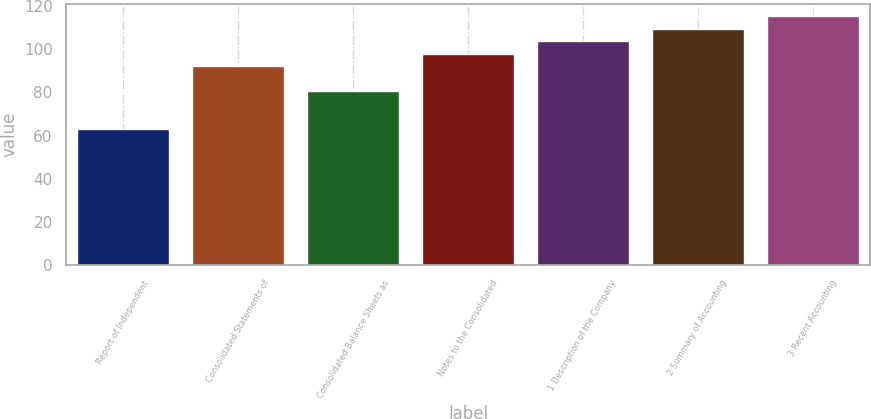Convert chart to OTSL. <chart><loc_0><loc_0><loc_500><loc_500><bar_chart><fcel>Report of Independent<fcel>Consolidated Statements of<fcel>Consolidated Balance Sheets as<fcel>Notes to the Consolidated<fcel>1 Description of the Company<fcel>2 Summary of Accounting<fcel>3 Recent Accounting<nl><fcel>63<fcel>92<fcel>80.4<fcel>97.8<fcel>103.6<fcel>109.4<fcel>115.2<nl></chart> 